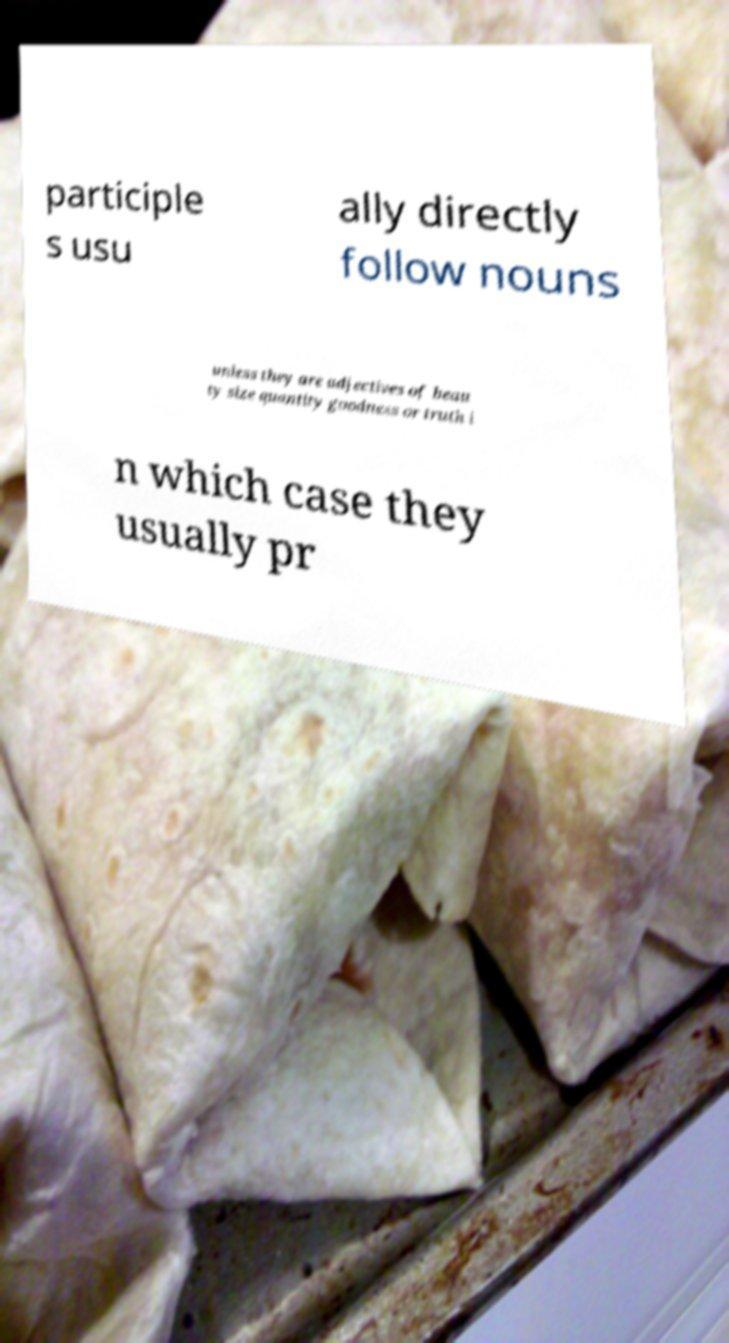Can you read and provide the text displayed in the image?This photo seems to have some interesting text. Can you extract and type it out for me? participle s usu ally directly follow nouns unless they are adjectives of beau ty size quantity goodness or truth i n which case they usually pr 